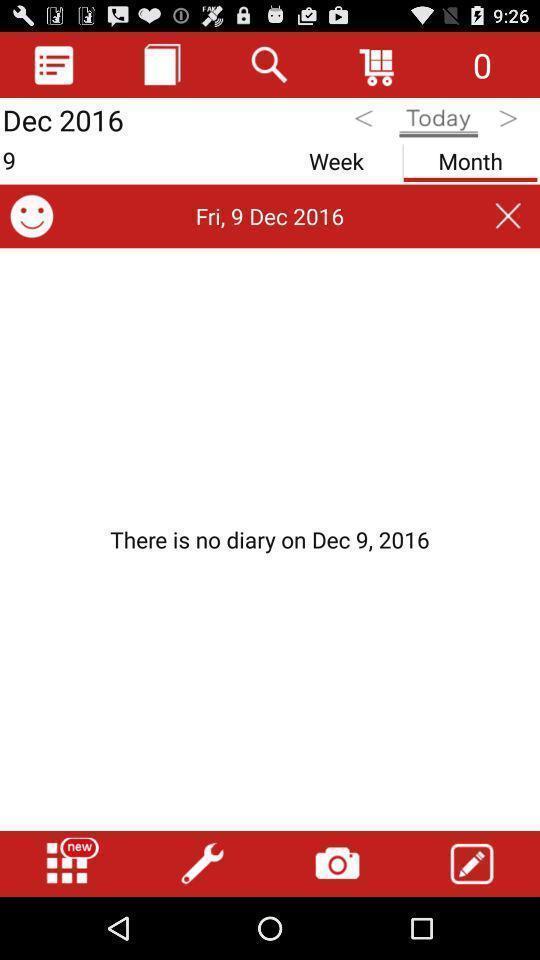Give me a narrative description of this picture. Page showing different options on an app. 